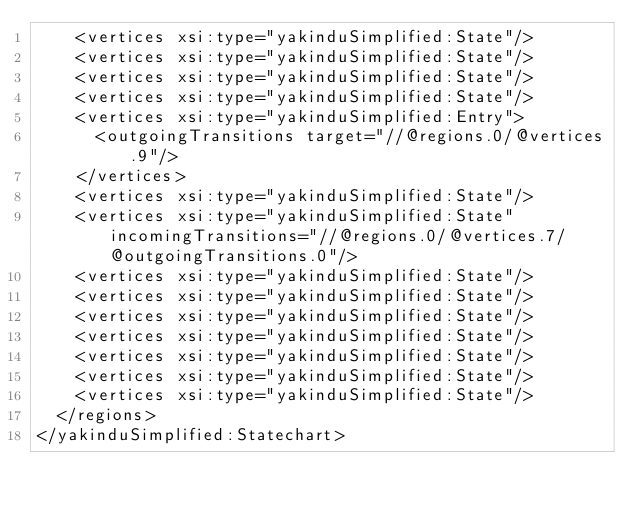Convert code to text. <code><loc_0><loc_0><loc_500><loc_500><_XML_>    <vertices xsi:type="yakinduSimplified:State"/>
    <vertices xsi:type="yakinduSimplified:State"/>
    <vertices xsi:type="yakinduSimplified:State"/>
    <vertices xsi:type="yakinduSimplified:State"/>
    <vertices xsi:type="yakinduSimplified:Entry">
      <outgoingTransitions target="//@regions.0/@vertices.9"/>
    </vertices>
    <vertices xsi:type="yakinduSimplified:State"/>
    <vertices xsi:type="yakinduSimplified:State" incomingTransitions="//@regions.0/@vertices.7/@outgoingTransitions.0"/>
    <vertices xsi:type="yakinduSimplified:State"/>
    <vertices xsi:type="yakinduSimplified:State"/>
    <vertices xsi:type="yakinduSimplified:State"/>
    <vertices xsi:type="yakinduSimplified:State"/>
    <vertices xsi:type="yakinduSimplified:State"/>
    <vertices xsi:type="yakinduSimplified:State"/>
    <vertices xsi:type="yakinduSimplified:State"/>
  </regions>
</yakinduSimplified:Statechart>
</code> 